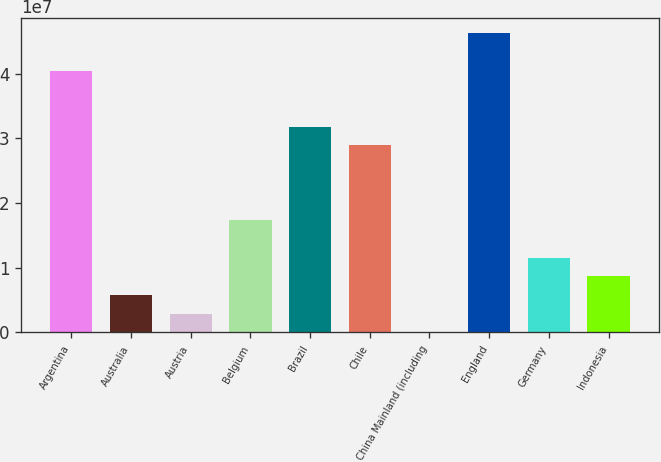Convert chart to OTSL. <chart><loc_0><loc_0><loc_500><loc_500><bar_chart><fcel>Argentina<fcel>Australia<fcel>Austria<fcel>Belgium<fcel>Brazil<fcel>Chile<fcel>China Mainland (including<fcel>England<fcel>Germany<fcel>Indonesia<nl><fcel>4.04303e+07<fcel>5.79335e+06<fcel>2.90693e+06<fcel>1.7339e+07<fcel>3.17711e+07<fcel>2.88847e+07<fcel>20518<fcel>4.62032e+07<fcel>1.15662e+07<fcel>8.67977e+06<nl></chart> 